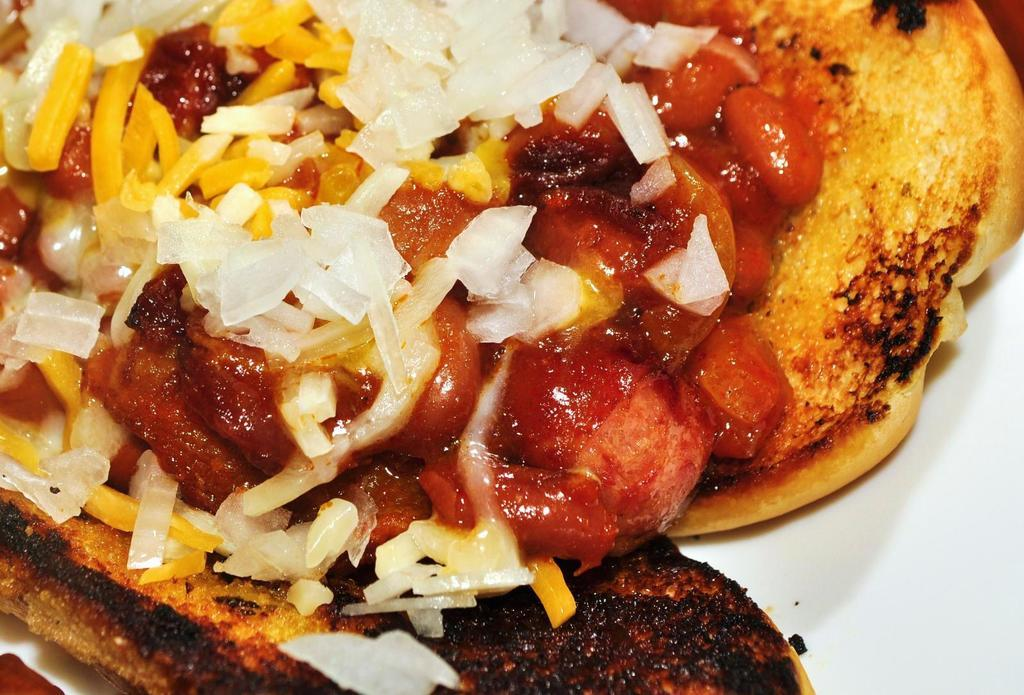What type of food can be seen in the image? There is food in the image, but the specific type is not mentioned. Are there any specific ingredients in the food? Yes, the food contains onions. How is the food presented in the image? The food is placed on a white plate. Can you see any bricks in the image? No, there are no bricks present in the image. Are there any animals from the zoo in the image? No, there are no animals from the zoo in the image. 